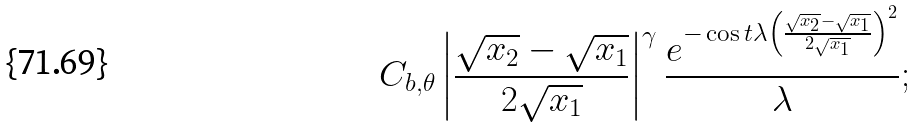<formula> <loc_0><loc_0><loc_500><loc_500>C _ { b , \theta } \left | \frac { \sqrt { x _ { 2 } } - \sqrt { x _ { 1 } } } { 2 \sqrt { x _ { 1 } } } \right | ^ { \gamma } \frac { e ^ { - \cos t \lambda \left ( \frac { \sqrt { x _ { 2 } } - \sqrt { x _ { 1 } } } { 2 \sqrt { x _ { 1 } } } \right ) ^ { 2 } } } { \lambda } ;</formula> 